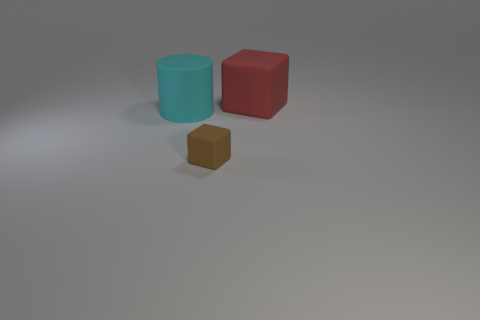Add 2 tiny brown metallic cylinders. How many objects exist? 5 Subtract all red blocks. How many blocks are left? 1 Subtract 1 cubes. How many cubes are left? 1 Subtract 0 yellow spheres. How many objects are left? 3 Subtract all blocks. How many objects are left? 1 Subtract all gray blocks. Subtract all brown balls. How many blocks are left? 2 Subtract all red blocks. Subtract all cylinders. How many objects are left? 1 Add 1 red matte cubes. How many red matte cubes are left? 2 Add 3 brown blocks. How many brown blocks exist? 4 